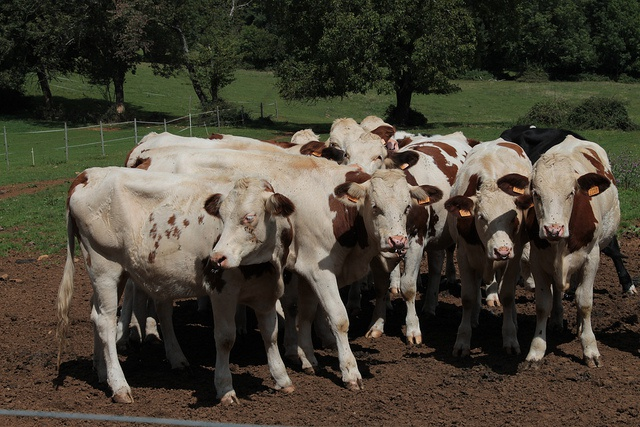Describe the objects in this image and their specific colors. I can see cow in black, darkgray, and gray tones, cow in black, darkgray, tan, and gray tones, cow in black, darkgray, and gray tones, cow in black, darkgray, tan, and gray tones, and cow in black, darkgray, maroon, and lightgray tones in this image. 